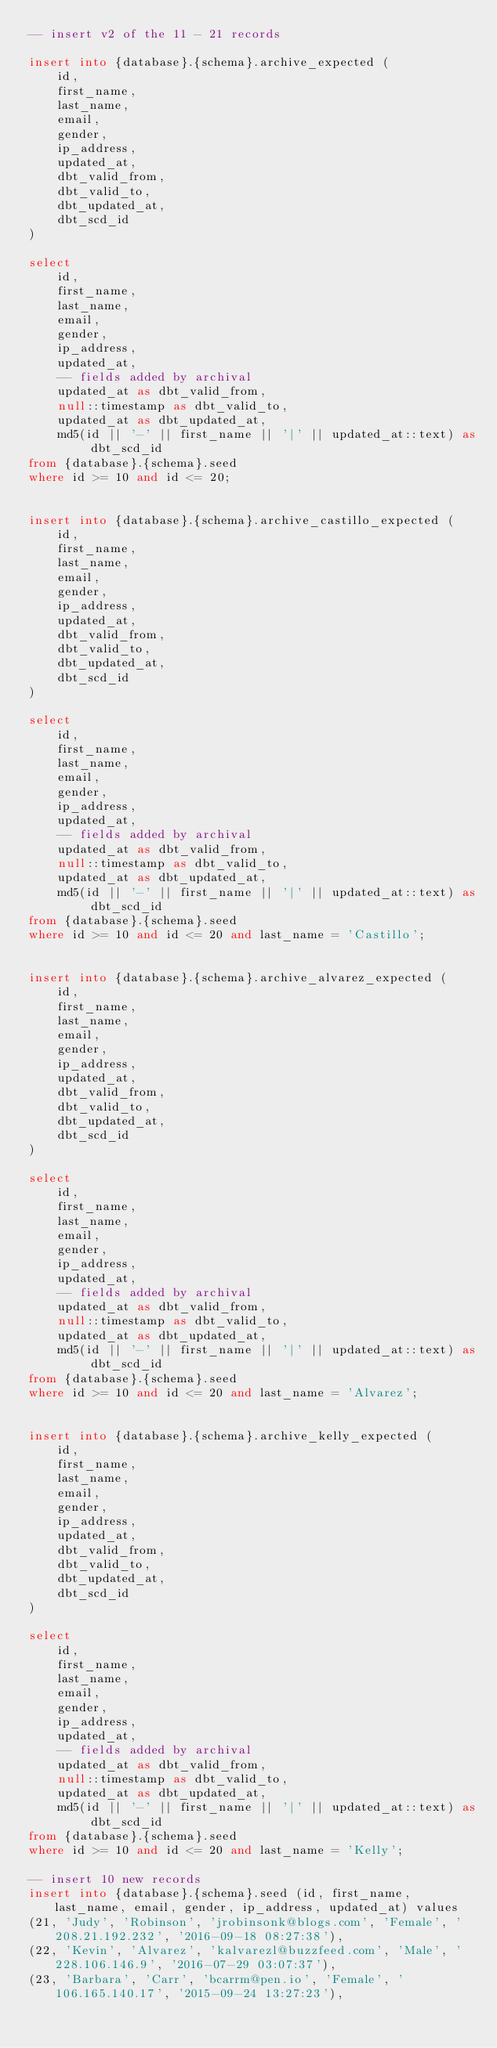<code> <loc_0><loc_0><loc_500><loc_500><_SQL_>-- insert v2 of the 11 - 21 records

insert into {database}.{schema}.archive_expected (
    id,
    first_name,
    last_name,
    email,
    gender,
    ip_address,
    updated_at,
    dbt_valid_from,
    dbt_valid_to,
    dbt_updated_at,
    dbt_scd_id
)

select
    id,
    first_name,
    last_name,
    email,
    gender,
    ip_address,
    updated_at,
    -- fields added by archival
    updated_at as dbt_valid_from,
    null::timestamp as dbt_valid_to,
    updated_at as dbt_updated_at,
    md5(id || '-' || first_name || '|' || updated_at::text) as dbt_scd_id
from {database}.{schema}.seed
where id >= 10 and id <= 20;


insert into {database}.{schema}.archive_castillo_expected (
    id,
    first_name,
    last_name,
    email,
    gender,
    ip_address,
    updated_at,
    dbt_valid_from,
    dbt_valid_to,
    dbt_updated_at,
    dbt_scd_id
)

select
    id,
    first_name,
    last_name,
    email,
    gender,
    ip_address,
    updated_at,
    -- fields added by archival
    updated_at as dbt_valid_from,
    null::timestamp as dbt_valid_to,
    updated_at as dbt_updated_at,
    md5(id || '-' || first_name || '|' || updated_at::text) as dbt_scd_id
from {database}.{schema}.seed
where id >= 10 and id <= 20 and last_name = 'Castillo';


insert into {database}.{schema}.archive_alvarez_expected (
    id,
    first_name,
    last_name,
    email,
    gender,
    ip_address,
    updated_at,
    dbt_valid_from,
    dbt_valid_to,
    dbt_updated_at,
    dbt_scd_id
)

select
    id,
    first_name,
    last_name,
    email,
    gender,
    ip_address,
    updated_at,
    -- fields added by archival
    updated_at as dbt_valid_from,
    null::timestamp as dbt_valid_to,
    updated_at as dbt_updated_at,
    md5(id || '-' || first_name || '|' || updated_at::text) as dbt_scd_id
from {database}.{schema}.seed
where id >= 10 and id <= 20 and last_name = 'Alvarez';


insert into {database}.{schema}.archive_kelly_expected (
    id,
    first_name,
    last_name,
    email,
    gender,
    ip_address,
    updated_at,
    dbt_valid_from,
    dbt_valid_to,
    dbt_updated_at,
    dbt_scd_id
)

select
    id,
    first_name,
    last_name,
    email,
    gender,
    ip_address,
    updated_at,
    -- fields added by archival
    updated_at as dbt_valid_from,
    null::timestamp as dbt_valid_to,
    updated_at as dbt_updated_at,
    md5(id || '-' || first_name || '|' || updated_at::text) as dbt_scd_id
from {database}.{schema}.seed
where id >= 10 and id <= 20 and last_name = 'Kelly';

-- insert 10 new records
insert into {database}.{schema}.seed (id, first_name, last_name, email, gender, ip_address, updated_at) values
(21, 'Judy', 'Robinson', 'jrobinsonk@blogs.com', 'Female', '208.21.192.232', '2016-09-18 08:27:38'),
(22, 'Kevin', 'Alvarez', 'kalvarezl@buzzfeed.com', 'Male', '228.106.146.9', '2016-07-29 03:07:37'),
(23, 'Barbara', 'Carr', 'bcarrm@pen.io', 'Female', '106.165.140.17', '2015-09-24 13:27:23'),</code> 